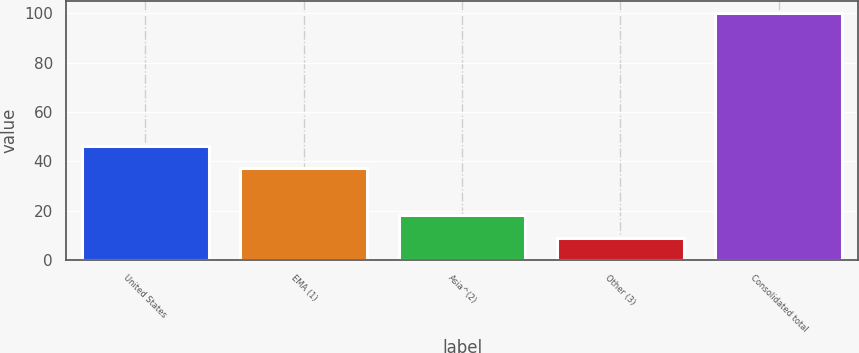<chart> <loc_0><loc_0><loc_500><loc_500><bar_chart><fcel>United States<fcel>EMA (1)<fcel>Asia^(2)<fcel>Other (3)<fcel>Consolidated total<nl><fcel>46.31<fcel>37.2<fcel>18.01<fcel>8.9<fcel>100<nl></chart> 